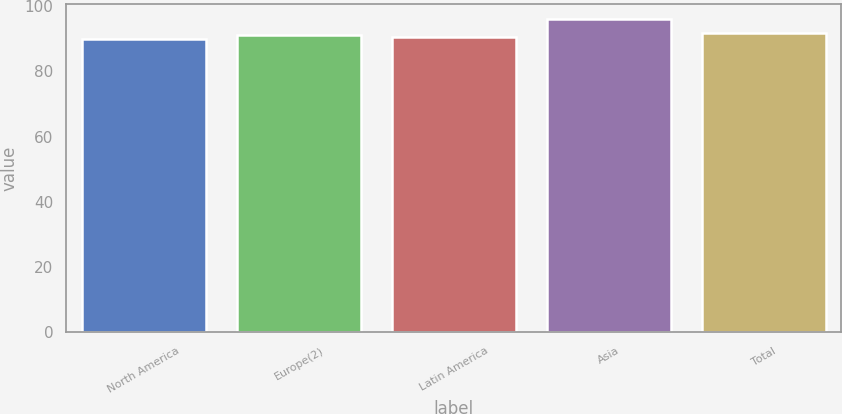<chart> <loc_0><loc_0><loc_500><loc_500><bar_chart><fcel>North America<fcel>Europe(2)<fcel>Latin America<fcel>Asia<fcel>Total<nl><fcel>90<fcel>91.2<fcel>90.6<fcel>96<fcel>91.8<nl></chart> 